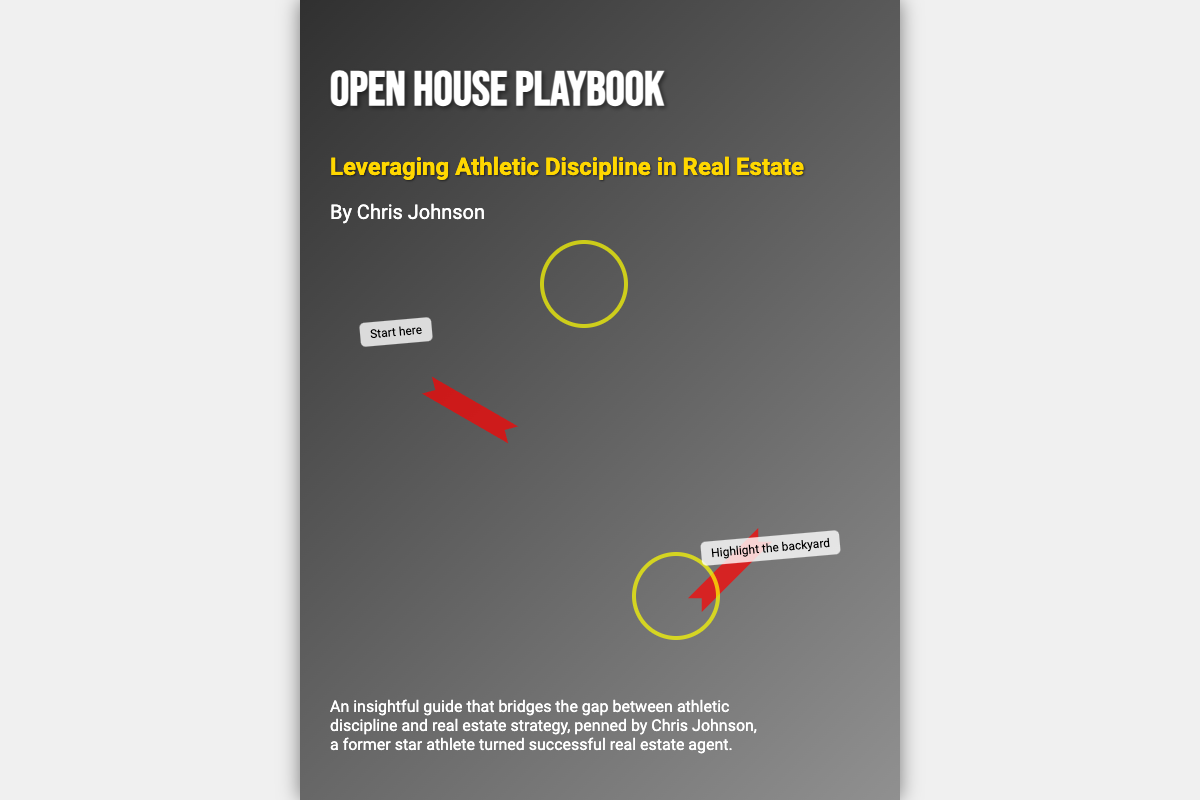what is the title of the book? The title is prominently displayed on the cover as "Open House Playbook."
Answer: Open House Playbook who is the author of the book? The author's name can be found in the author section of the cover, which states "By Chris Johnson."
Answer: Chris Johnson what is the subtitle of the book? The subtitle is presented just below the title and is "Leveraging Athletic Discipline in Real Estate."
Answer: Leveraging Athletic Discipline in Real Estate how many arrows are depicted on the cover? The number of arrows can be visually counted from the cover; there are two arrows.
Answer: 2 what color is used for the subtitle? The subtitle color is specifically mentioned in the document as "gold."
Answer: gold what kind of background image is used on the cover? The background image features an "Open House" scene, suggesting a real estate theme.
Answer: Open House what is the primary theme of the book? The book's theme revolves around "bridging the gap between athletic discipline and real estate strategy."
Answer: bridging the gap between athletic discipline and real estate strategy what is a specific note mentioned in the playbook elements? The document describes a note that is positioned stating "Highlight the backyard."
Answer: Highlight the backyard what is the color of the author's name text? The color of the author's name is indicated as "white."
Answer: white what shape is used in the playbook elements? There is a specific element that is a "circle" used in the playbook design.
Answer: circle 